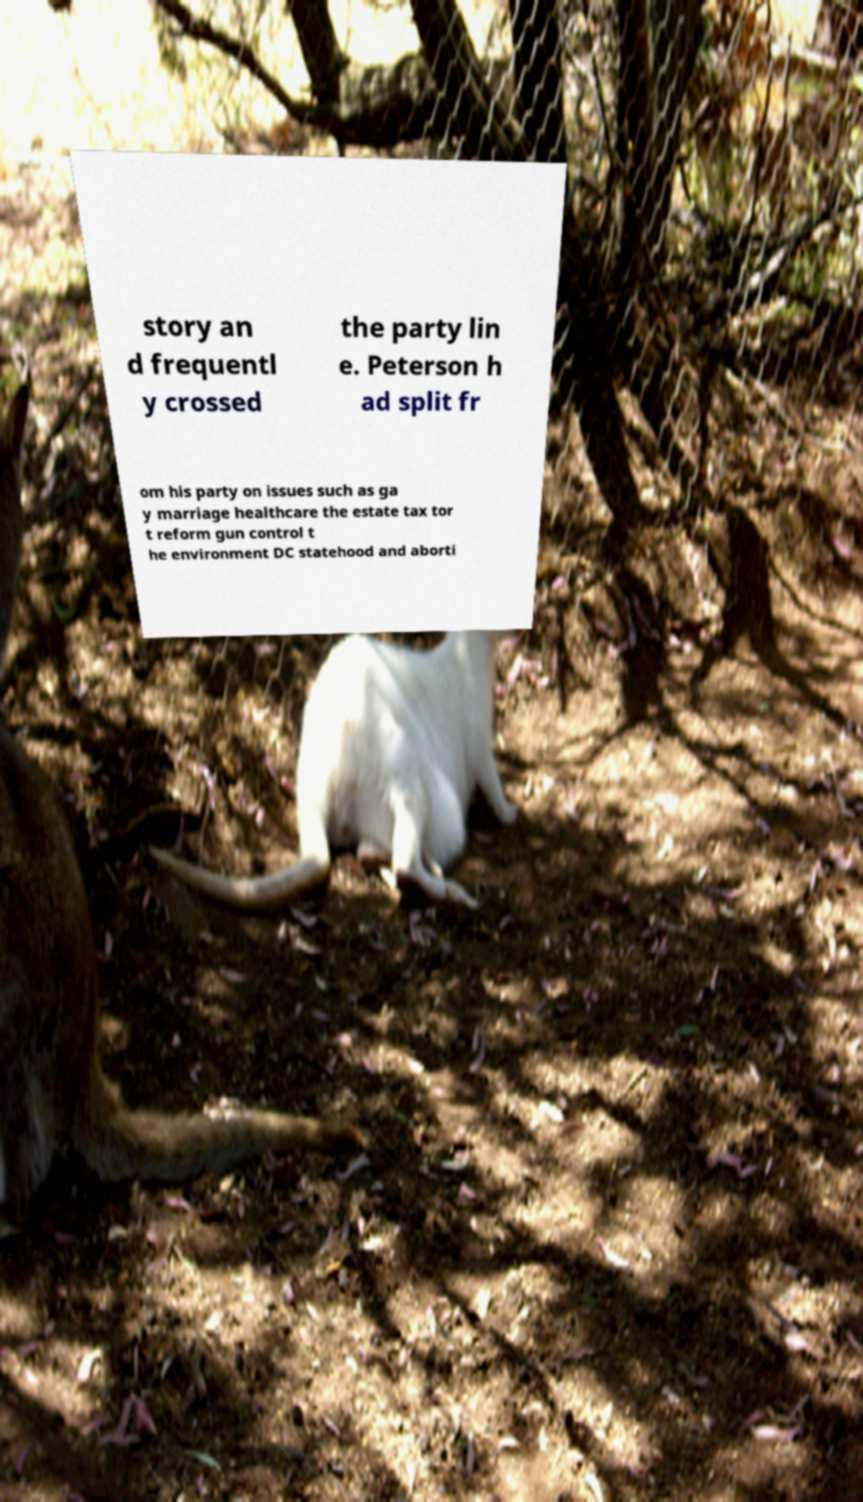For documentation purposes, I need the text within this image transcribed. Could you provide that? story an d frequentl y crossed the party lin e. Peterson h ad split fr om his party on issues such as ga y marriage healthcare the estate tax tor t reform gun control t he environment DC statehood and aborti 